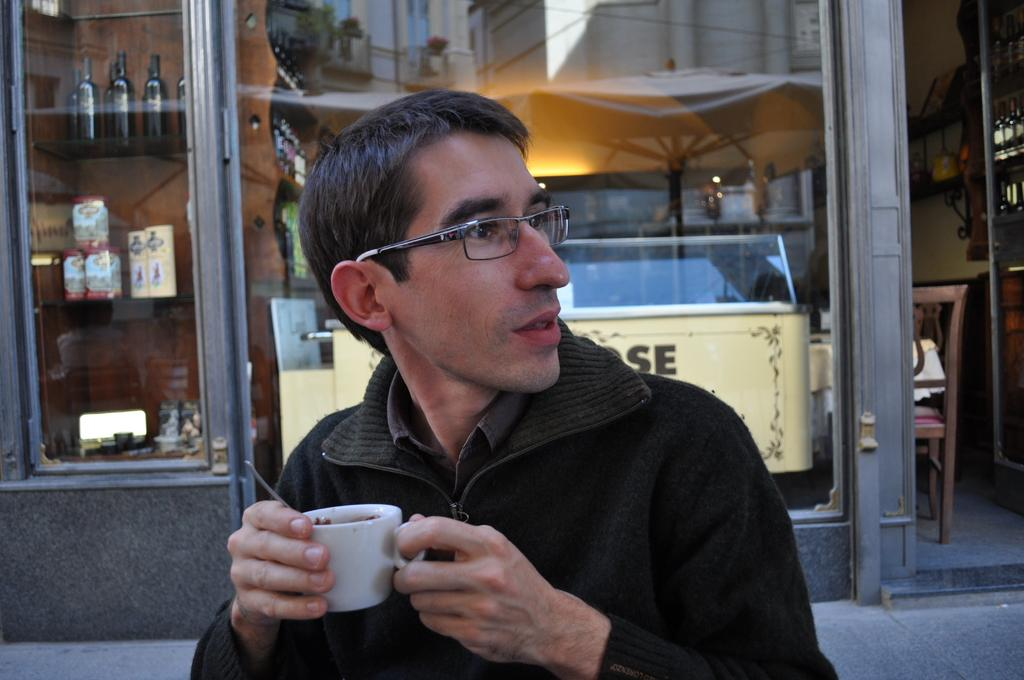Who is present in the image? There is a man in the image. What is the man wearing? The man is wearing spectacles. What is the man holding in his hands? The man is holding a cup in his hands. What can be seen in the background of the image? There is a glass window in the background of the image. What is visible through the glass window? Bottles are visible through the glass window. What type of development is taking place in the man's territory in the image? There is no indication of any development or territory in the image; it simply features a man holding a cup and wearing spectacles. 